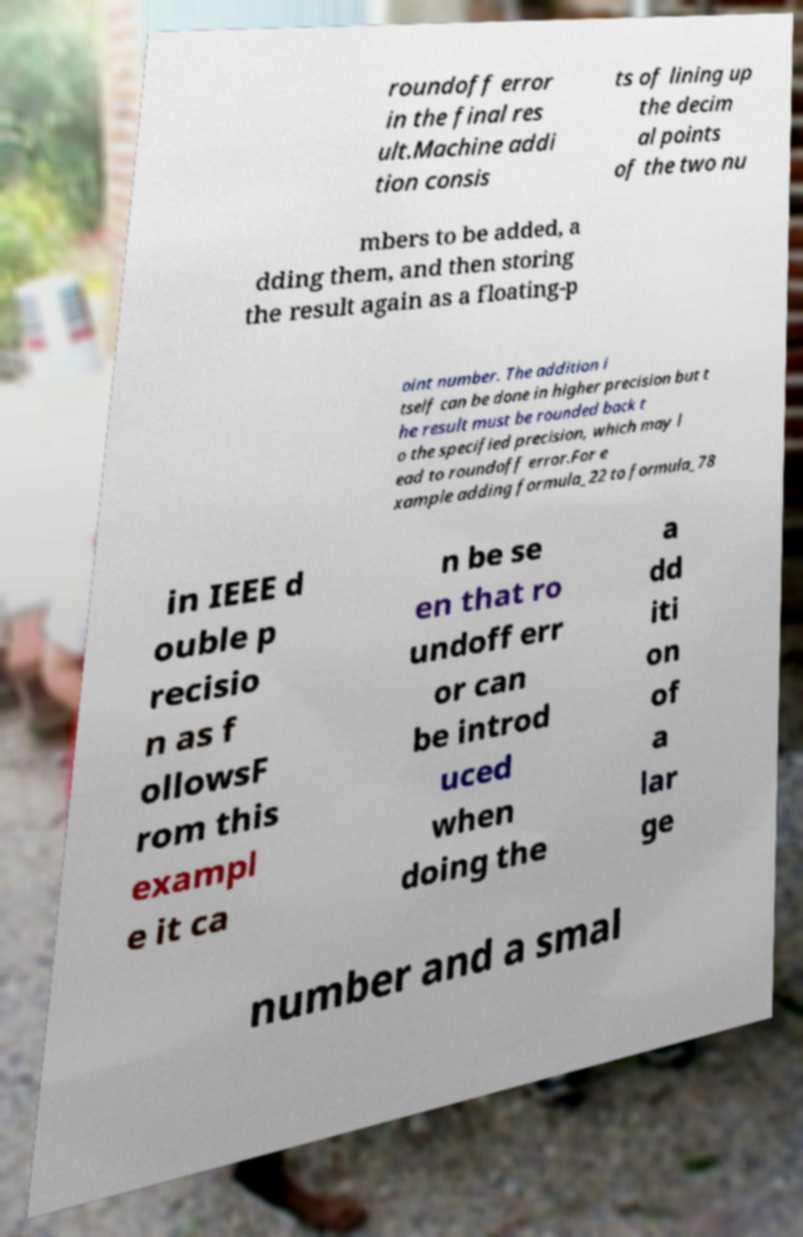Can you read and provide the text displayed in the image?This photo seems to have some interesting text. Can you extract and type it out for me? roundoff error in the final res ult.Machine addi tion consis ts of lining up the decim al points of the two nu mbers to be added, a dding them, and then storing the result again as a floating-p oint number. The addition i tself can be done in higher precision but t he result must be rounded back t o the specified precision, which may l ead to roundoff error.For e xample adding formula_22 to formula_78 in IEEE d ouble p recisio n as f ollowsF rom this exampl e it ca n be se en that ro undoff err or can be introd uced when doing the a dd iti on of a lar ge number and a smal 